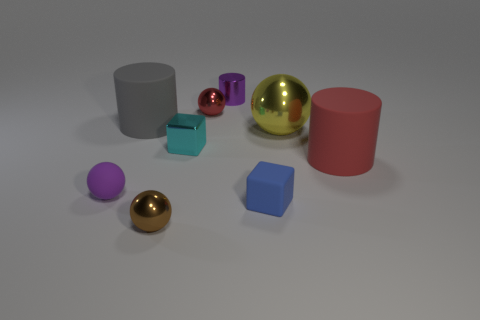Subtract all big cylinders. How many cylinders are left? 1 Subtract all blocks. How many objects are left? 7 Subtract all yellow balls. How many balls are left? 3 Subtract 2 cubes. How many cubes are left? 0 Add 8 yellow spheres. How many yellow spheres are left? 9 Add 1 small brown spheres. How many small brown spheres exist? 2 Subtract 1 red cylinders. How many objects are left? 8 Subtract all green spheres. Subtract all red blocks. How many spheres are left? 4 Subtract all small blue blocks. Subtract all big rubber things. How many objects are left? 6 